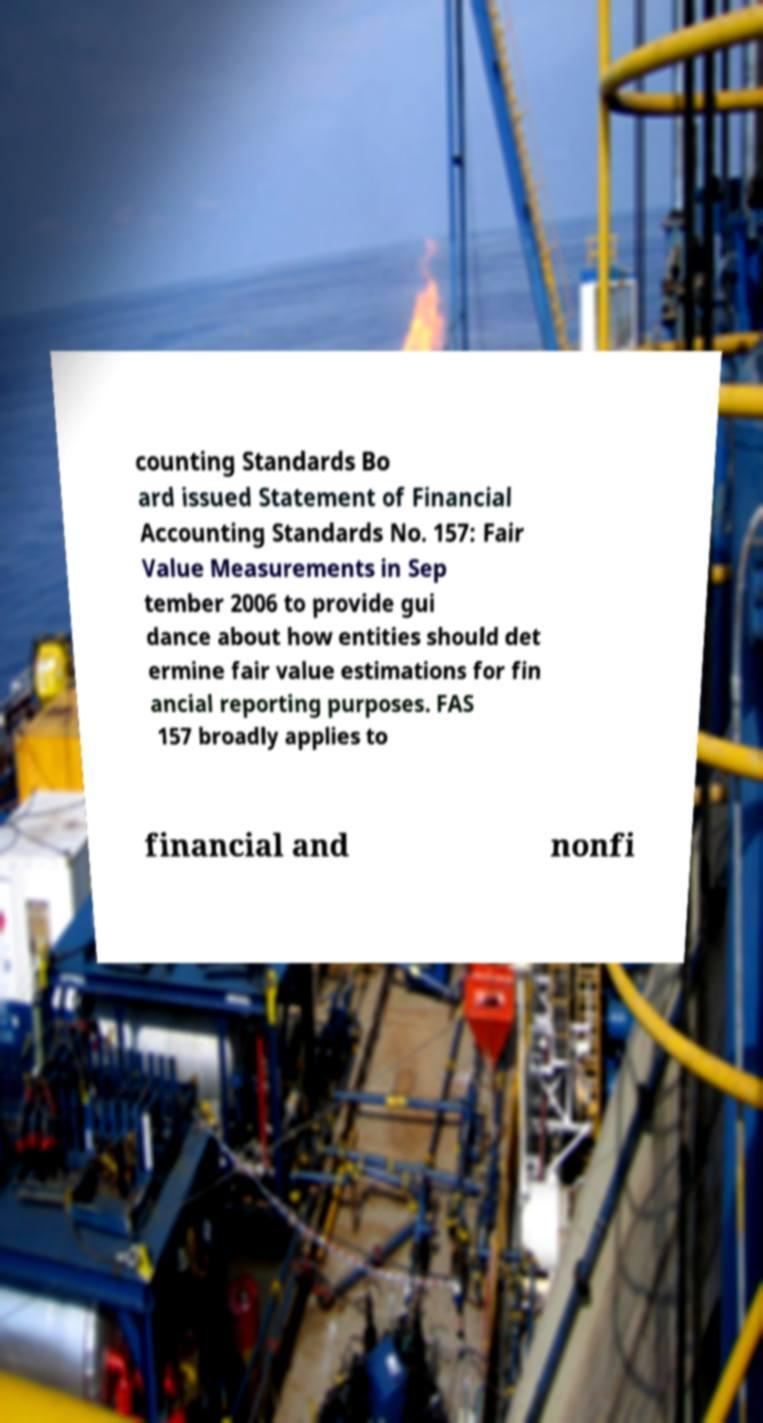I need the written content from this picture converted into text. Can you do that? counting Standards Bo ard issued Statement of Financial Accounting Standards No. 157: Fair Value Measurements in Sep tember 2006 to provide gui dance about how entities should det ermine fair value estimations for fin ancial reporting purposes. FAS 157 broadly applies to financial and nonfi 